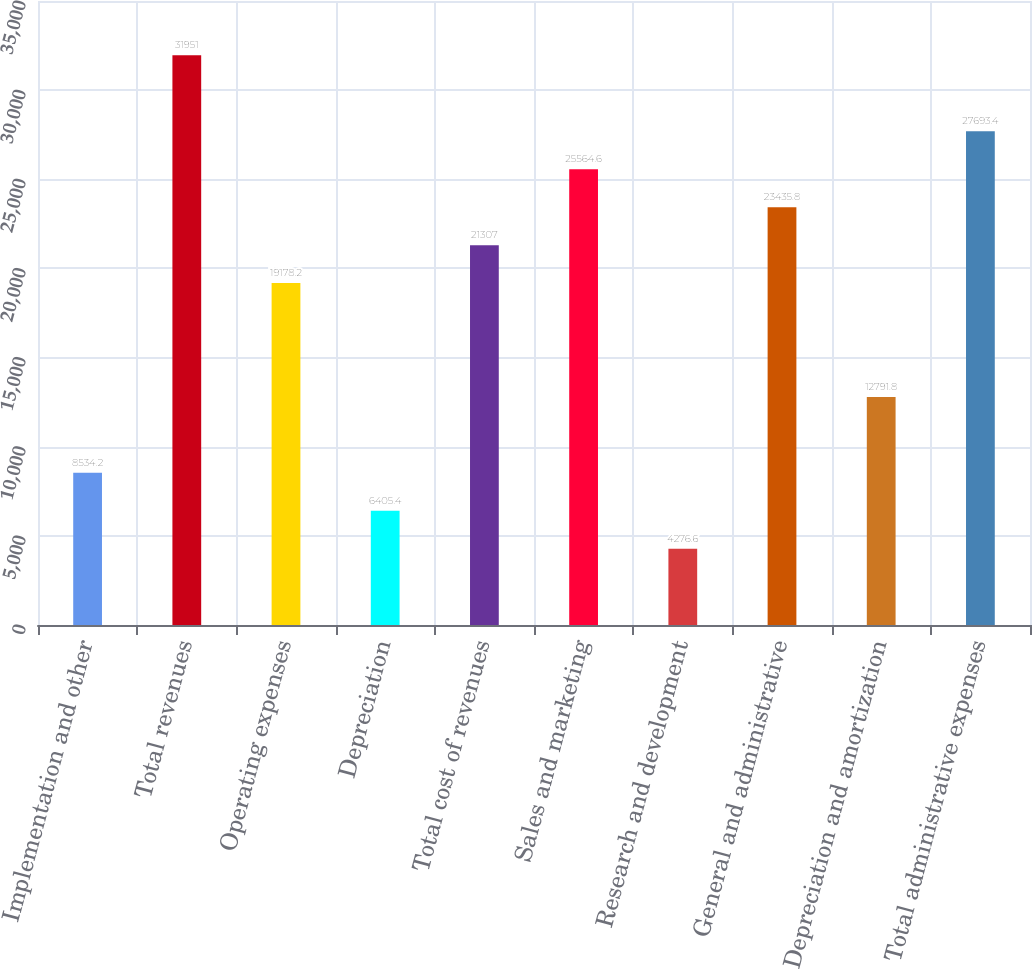<chart> <loc_0><loc_0><loc_500><loc_500><bar_chart><fcel>Implementation and other<fcel>Total revenues<fcel>Operating expenses<fcel>Depreciation<fcel>Total cost of revenues<fcel>Sales and marketing<fcel>Research and development<fcel>General and administrative<fcel>Depreciation and amortization<fcel>Total administrative expenses<nl><fcel>8534.2<fcel>31951<fcel>19178.2<fcel>6405.4<fcel>21307<fcel>25564.6<fcel>4276.6<fcel>23435.8<fcel>12791.8<fcel>27693.4<nl></chart> 